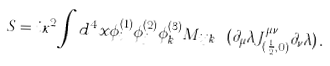<formula> <loc_0><loc_0><loc_500><loc_500>S = i \kappa ^ { 2 } \int d ^ { 4 } x \phi ^ { ( 1 ) } _ { i } \phi ^ { ( 2 ) } _ { j } \phi ^ { ( 3 ) } _ { k } M _ { i j k } \ ( \partial _ { \mu } \lambda J ^ { \mu \nu } _ { ( \frac { 1 } { 2 } , 0 ) } \partial _ { \nu } \lambda ) \, .</formula> 